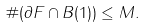Convert formula to latex. <formula><loc_0><loc_0><loc_500><loc_500>\# ( \partial F \cap B ( 1 ) ) \leq M .</formula> 